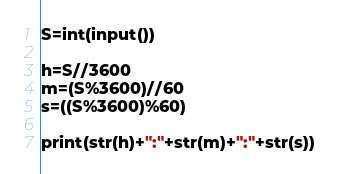<code> <loc_0><loc_0><loc_500><loc_500><_Python_>S=int(input())

h=S//3600
m=(S%3600)//60
s=((S%3600)%60)

print(str(h)+":"+str(m)+":"+str(s))
</code> 